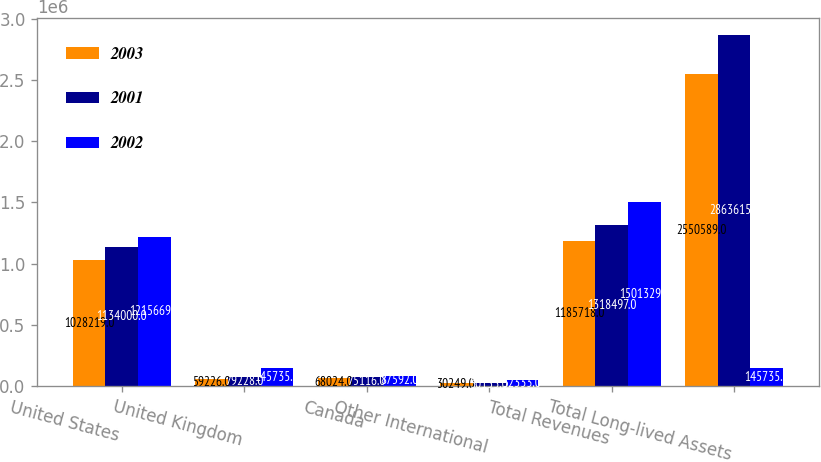<chart> <loc_0><loc_0><loc_500><loc_500><stacked_bar_chart><ecel><fcel>United States<fcel>United Kingdom<fcel>Canada<fcel>Other International<fcel>Total Revenues<fcel>Total Long-lived Assets<nl><fcel>2003<fcel>1.02822e+06<fcel>59226<fcel>68024<fcel>30249<fcel>1.18572e+06<fcel>2.55059e+06<nl><fcel>2001<fcel>1.134e+06<fcel>79228<fcel>75116<fcel>30153<fcel>1.3185e+06<fcel>2.86362e+06<nl><fcel>2002<fcel>1.21567e+06<fcel>145735<fcel>87592<fcel>52333<fcel>1.50133e+06<fcel>145735<nl></chart> 